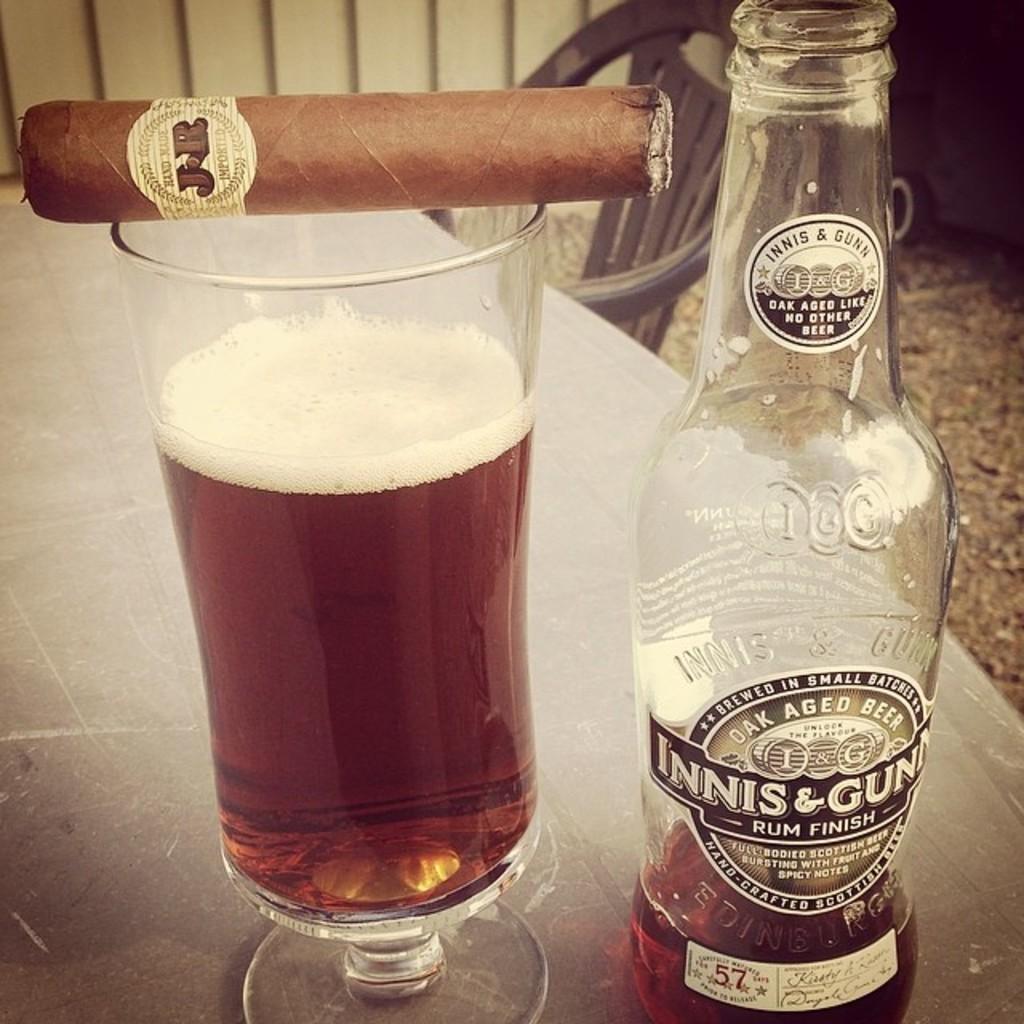What type of finish did this beer undergo?
Your answer should be very brief. Rum. What brand of beer is it?
Give a very brief answer. Innis & gunn. 